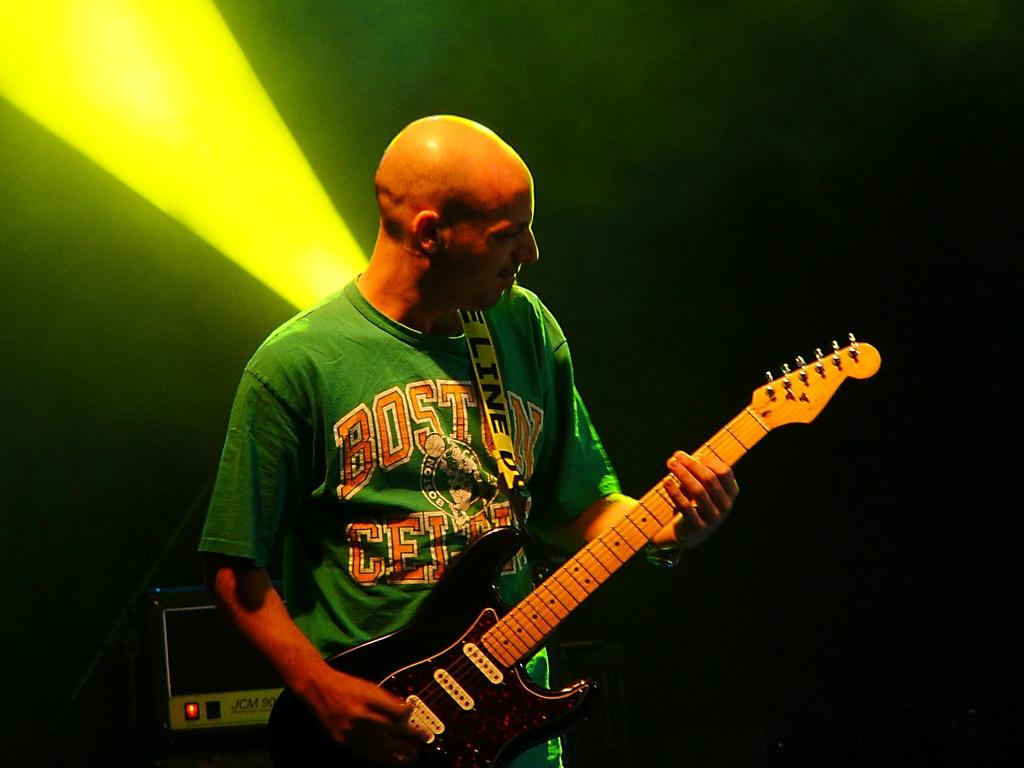What is the main subject of the image? There is a man in the image. What is the man holding in the image? The man is holding a guitar. What word is being spelled out by the man in the image? There is no indication in the image that the man is spelling out a word. 